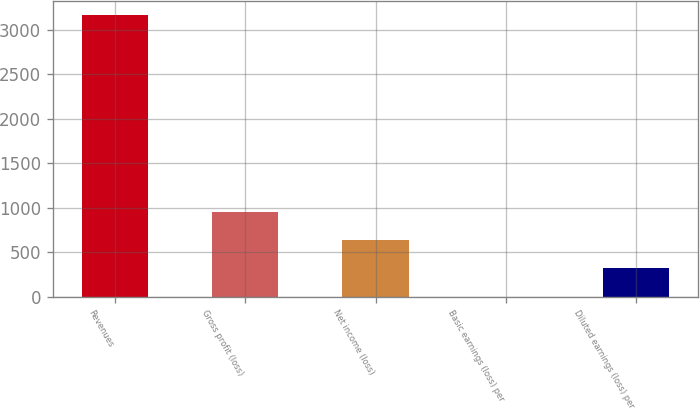Convert chart. <chart><loc_0><loc_0><loc_500><loc_500><bar_chart><fcel>Revenues<fcel>Gross profit (loss)<fcel>Net income (loss)<fcel>Basic earnings (loss) per<fcel>Diluted earnings (loss) per<nl><fcel>3172.4<fcel>951.82<fcel>634.6<fcel>0.16<fcel>317.38<nl></chart> 